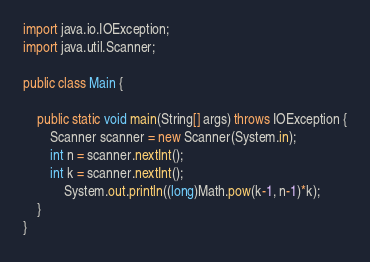<code> <loc_0><loc_0><loc_500><loc_500><_Java_>import java.io.IOException;
import java.util.Scanner;

public class Main {

	public static void main(String[] args) throws IOException {
		Scanner scanner = new Scanner(System.in);
		int n = scanner.nextInt();
		int k = scanner.nextInt();
			System.out.println((long)Math.pow(k-1, n-1)*k);
	}
}</code> 